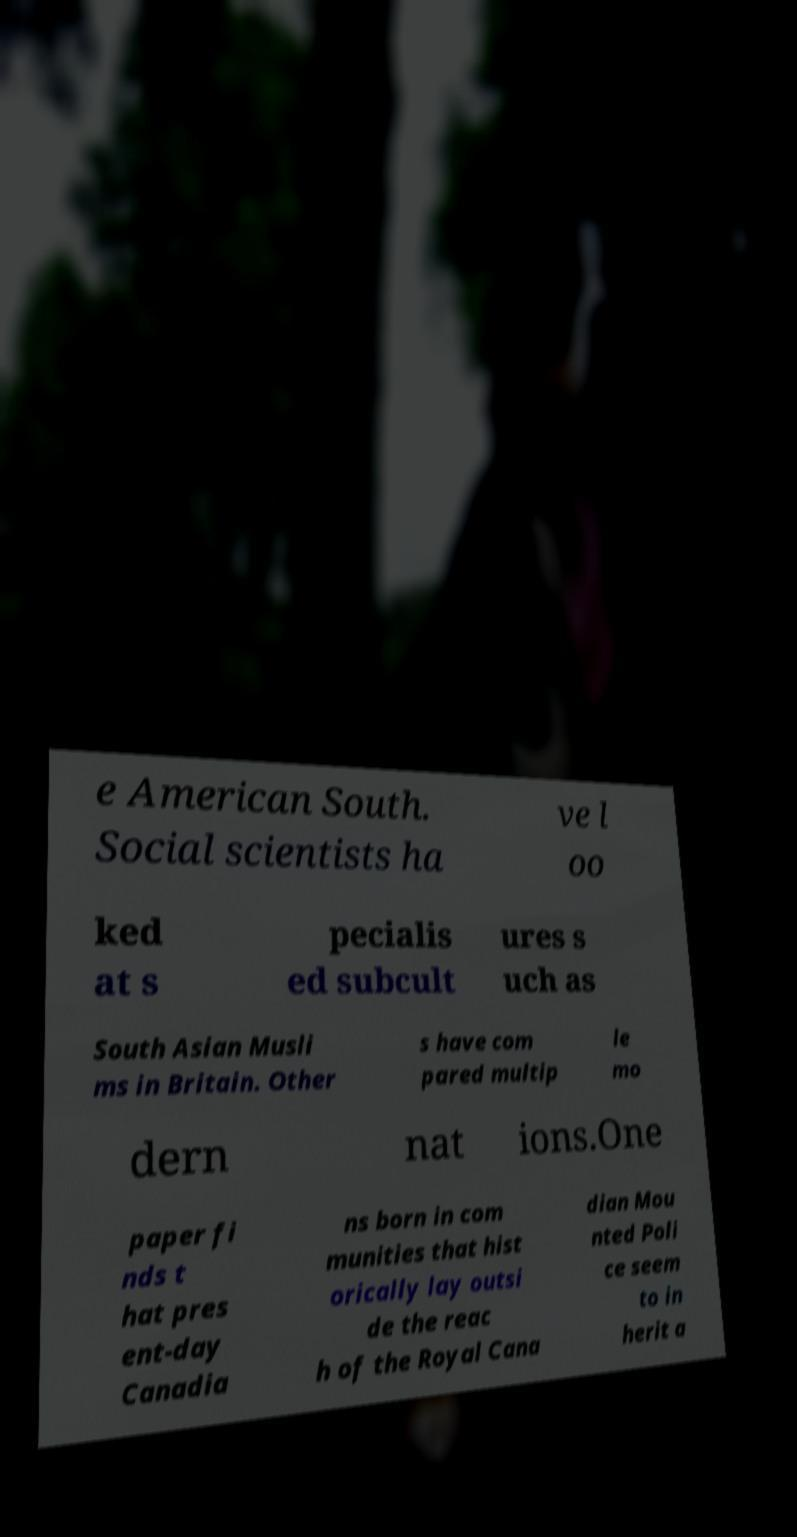There's text embedded in this image that I need extracted. Can you transcribe it verbatim? e American South. Social scientists ha ve l oo ked at s pecialis ed subcult ures s uch as South Asian Musli ms in Britain. Other s have com pared multip le mo dern nat ions.One paper fi nds t hat pres ent-day Canadia ns born in com munities that hist orically lay outsi de the reac h of the Royal Cana dian Mou nted Poli ce seem to in herit a 